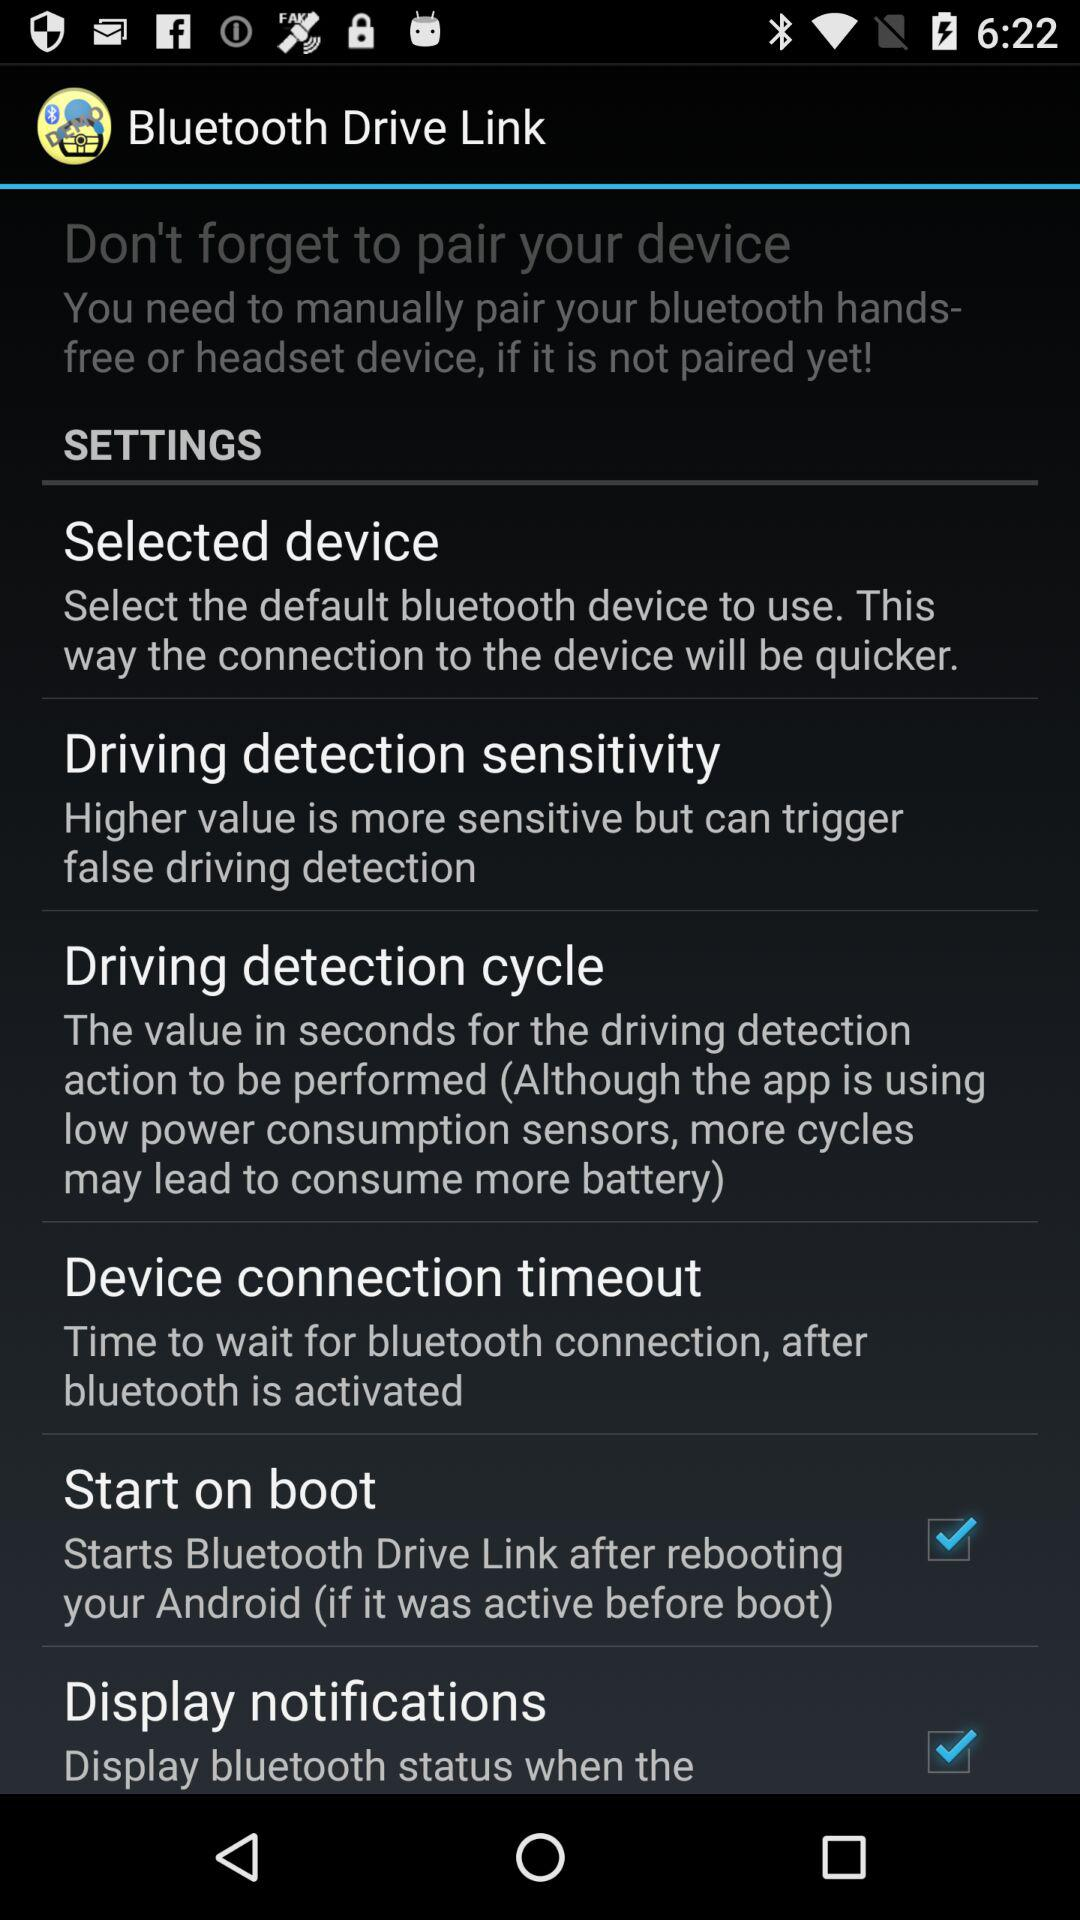What is the status of the "Start on boot"? The status of the "Start on boot" is "on". 